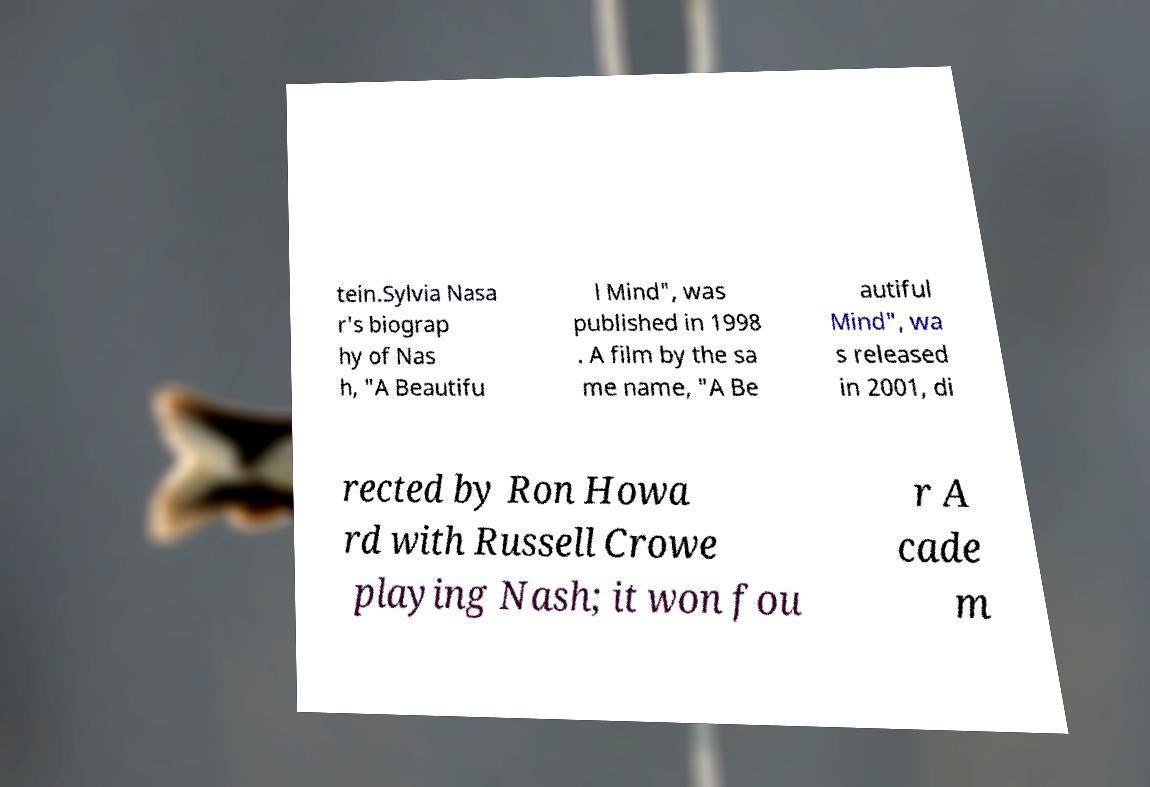Can you accurately transcribe the text from the provided image for me? tein.Sylvia Nasa r's biograp hy of Nas h, "A Beautifu l Mind", was published in 1998 . A film by the sa me name, "A Be autiful Mind", wa s released in 2001, di rected by Ron Howa rd with Russell Crowe playing Nash; it won fou r A cade m 